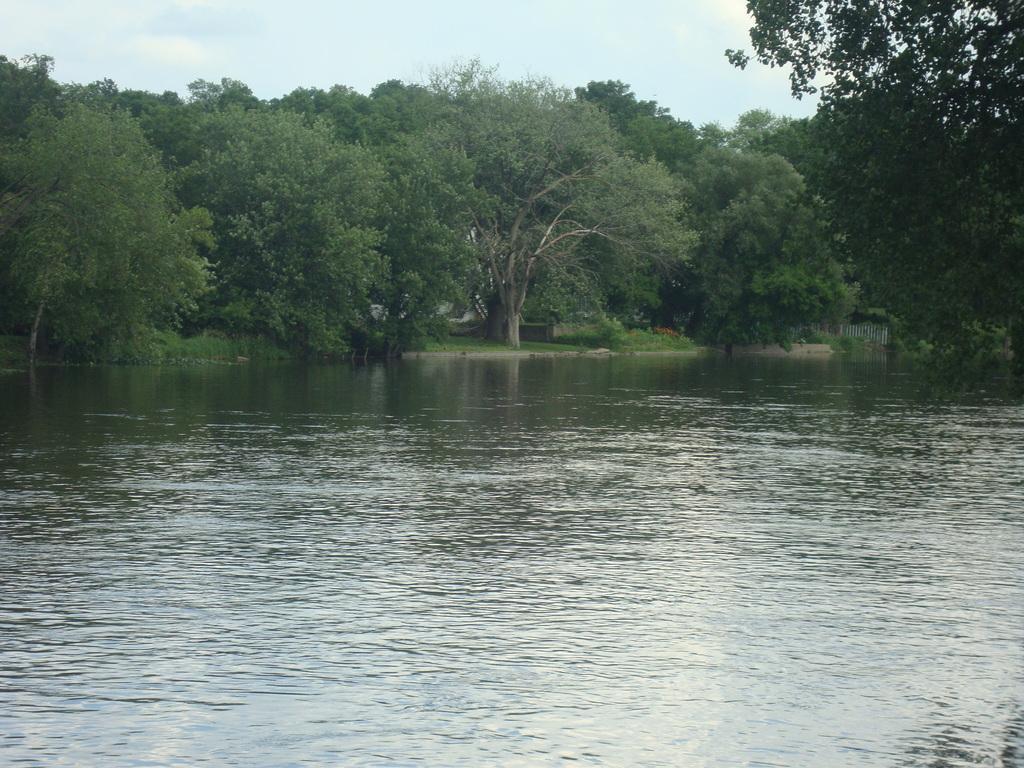In one or two sentences, can you explain what this image depicts? In this image there is water in the middle. In the background there are trees. At the top there is the sky. 